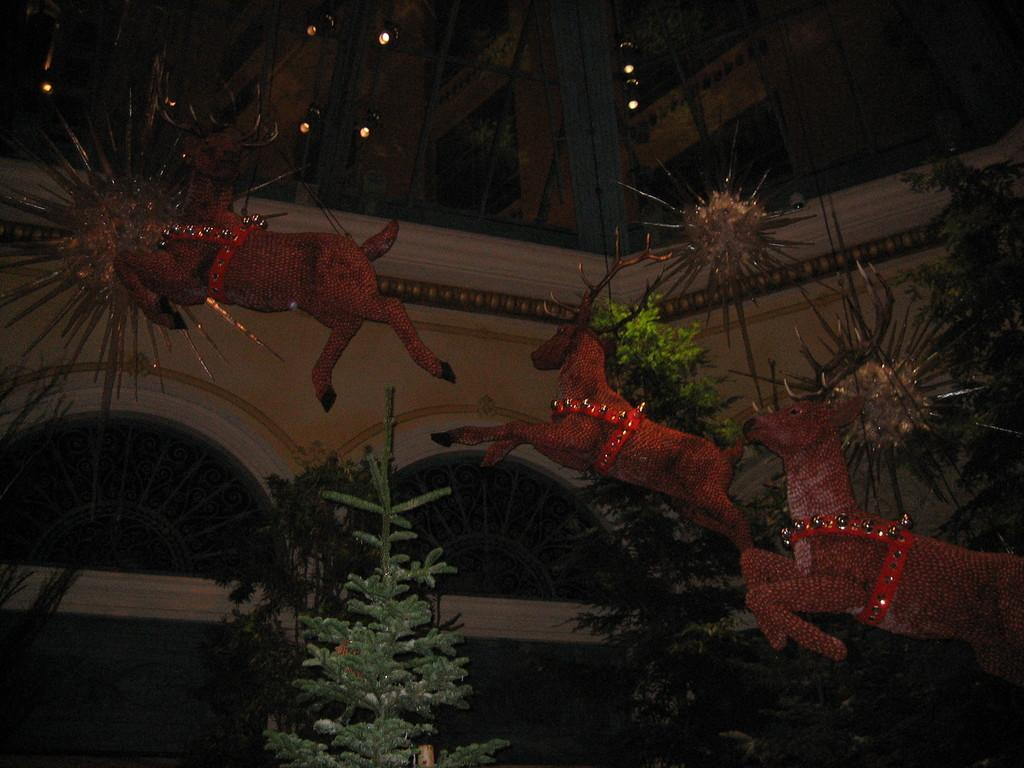What type of structure is present in the image? There is a building in the image. What features can be observed on the building? The building has windows and lights. What else can be seen in the image besides the building? There are plants, a depiction of animals, and other objects in the image. How many cats are sitting on the cent in the image? There are no cats or cents present in the image. 